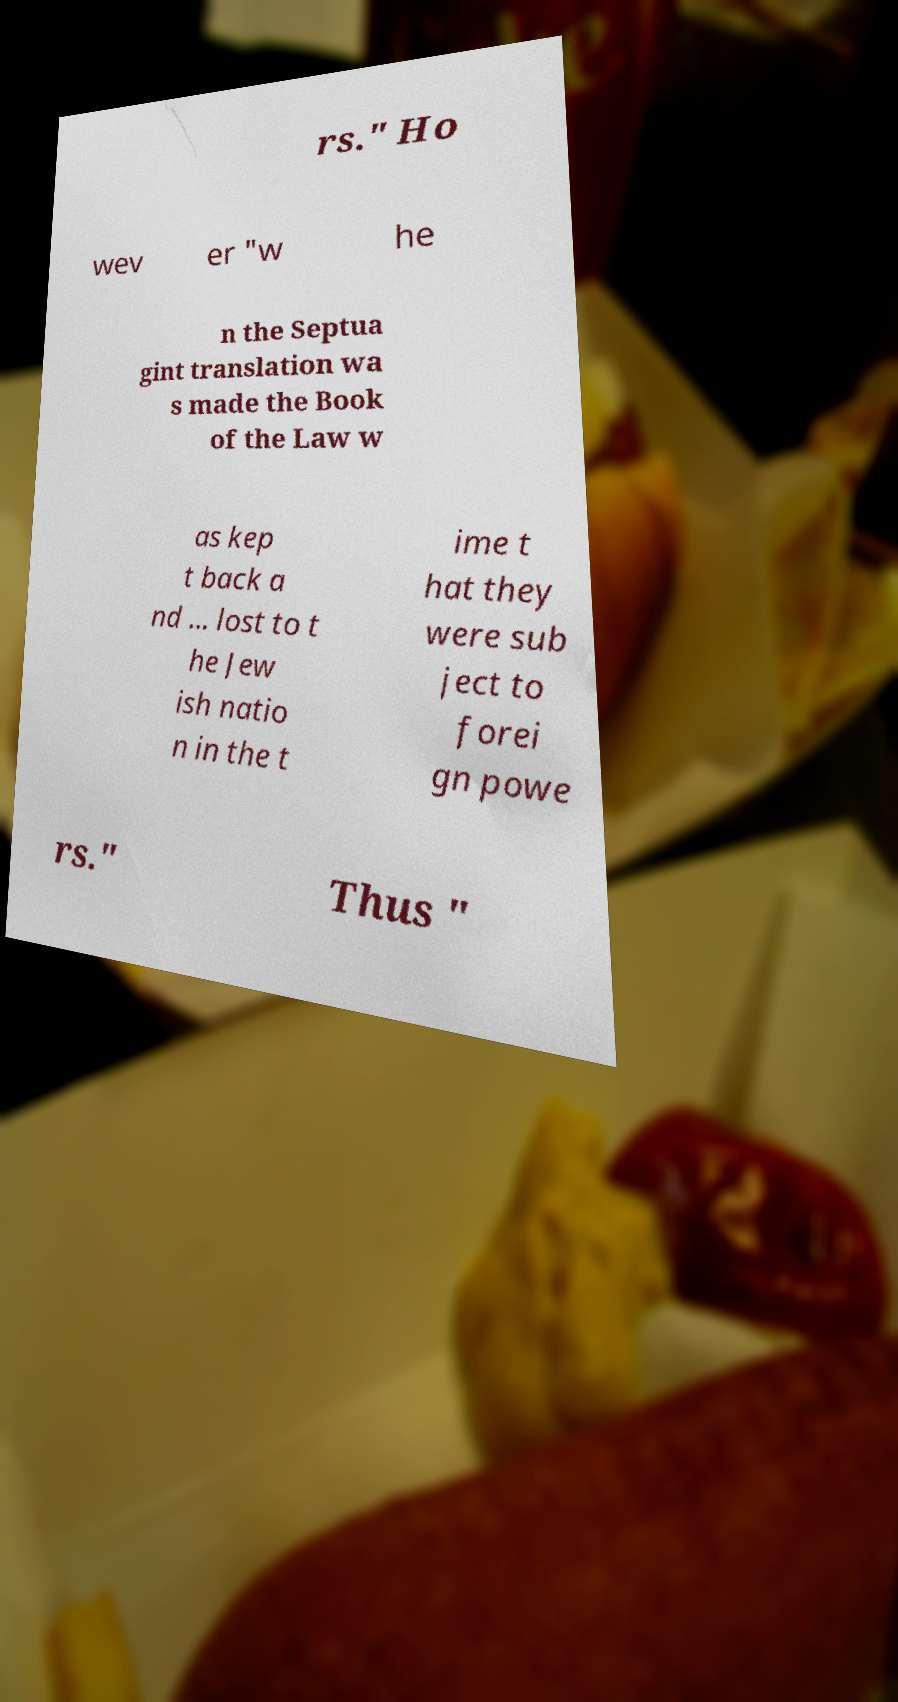Can you accurately transcribe the text from the provided image for me? rs." Ho wev er "w he n the Septua gint translation wa s made the Book of the Law w as kep t back a nd ... lost to t he Jew ish natio n in the t ime t hat they were sub ject to forei gn powe rs." Thus " 